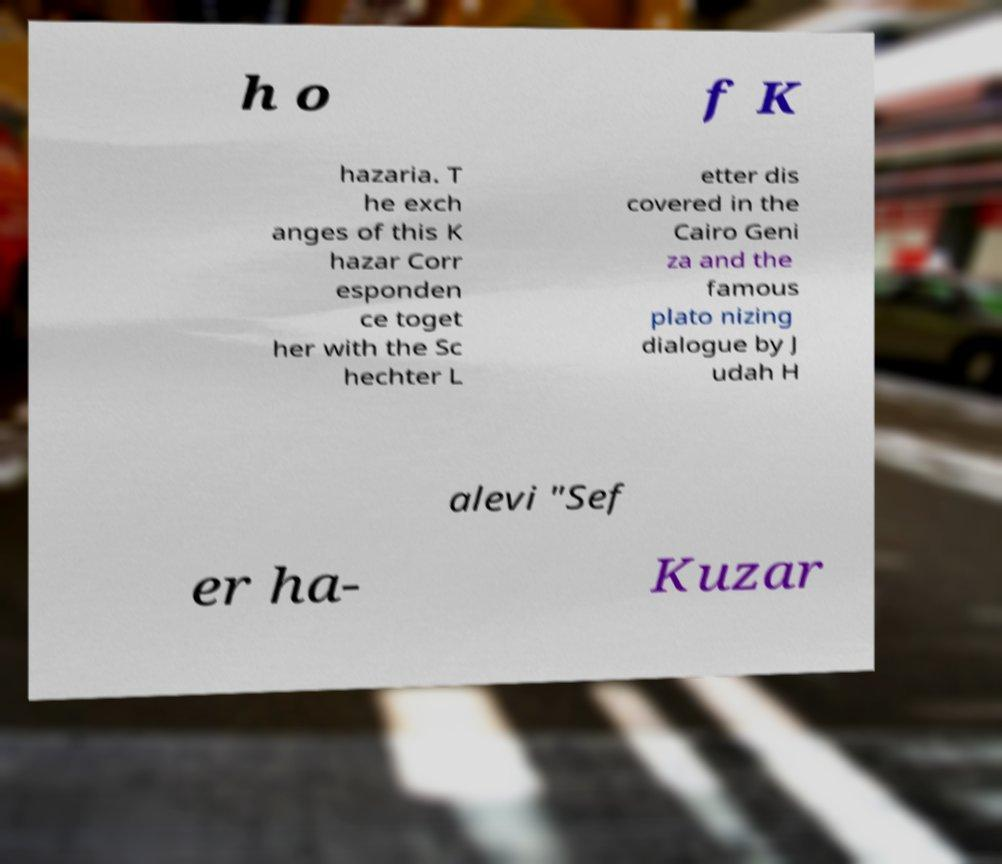Could you extract and type out the text from this image? h o f K hazaria. T he exch anges of this K hazar Corr esponden ce toget her with the Sc hechter L etter dis covered in the Cairo Geni za and the famous plato nizing dialogue by J udah H alevi "Sef er ha- Kuzar 